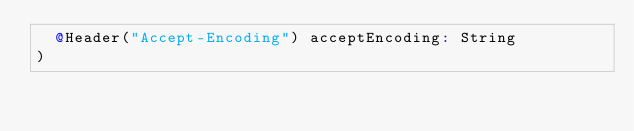Convert code to text. <code><loc_0><loc_0><loc_500><loc_500><_Scala_>  @Header("Accept-Encoding") acceptEncoding: String
)
</code> 